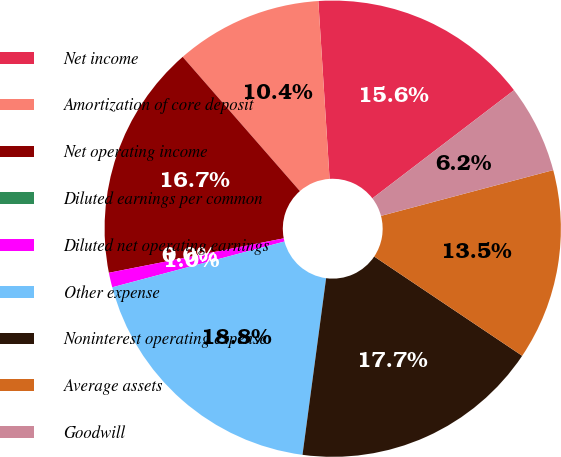<chart> <loc_0><loc_0><loc_500><loc_500><pie_chart><fcel>Net income<fcel>Amortization of core deposit<fcel>Net operating income<fcel>Diluted earnings per common<fcel>Diluted net operating earnings<fcel>Other expense<fcel>Noninterest operating expense<fcel>Average assets<fcel>Goodwill<nl><fcel>15.62%<fcel>10.42%<fcel>16.67%<fcel>0.0%<fcel>1.04%<fcel>18.75%<fcel>17.71%<fcel>13.54%<fcel>6.25%<nl></chart> 